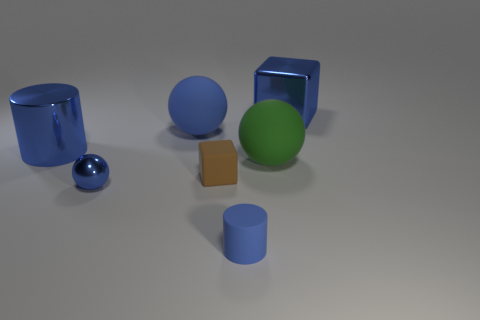What number of things are small brown rubber cubes or large green balls?
Your answer should be very brief. 2. Do the big matte object that is to the left of the brown rubber block and the big blue metal object right of the large cylinder have the same shape?
Your response must be concise. No. How many big objects are behind the green sphere and to the right of the big blue rubber object?
Offer a terse response. 1. How many other objects are the same size as the blue shiny ball?
Provide a succinct answer. 2. What is the sphere that is to the left of the brown matte block and right of the tiny metallic object made of?
Keep it short and to the point. Rubber. Does the small metallic ball have the same color as the large sphere that is to the right of the brown matte thing?
Offer a very short reply. No. There is another rubber object that is the same shape as the large green matte thing; what size is it?
Your response must be concise. Large. The blue metallic object that is behind the tiny brown block and in front of the blue shiny block has what shape?
Offer a very short reply. Cylinder. Is the size of the blue metal block the same as the matte ball that is to the right of the small cylinder?
Provide a succinct answer. Yes. The other matte thing that is the same shape as the big green matte object is what color?
Offer a terse response. Blue. 